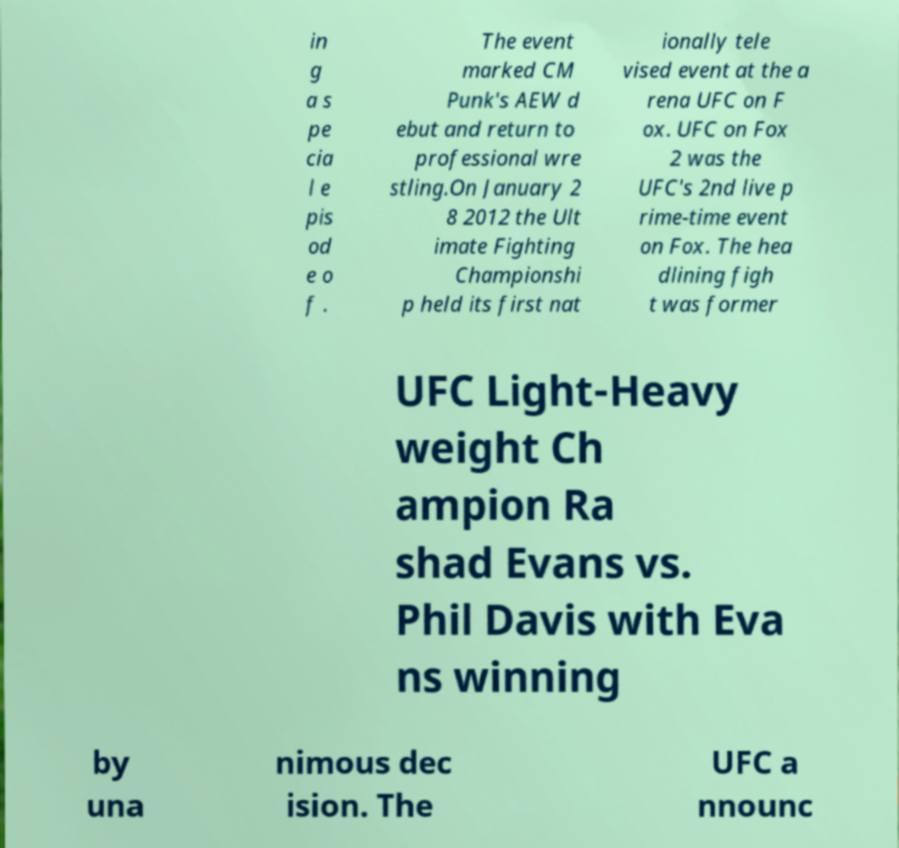There's text embedded in this image that I need extracted. Can you transcribe it verbatim? in g a s pe cia l e pis od e o f . The event marked CM Punk's AEW d ebut and return to professional wre stling.On January 2 8 2012 the Ult imate Fighting Championshi p held its first nat ionally tele vised event at the a rena UFC on F ox. UFC on Fox 2 was the UFC's 2nd live p rime-time event on Fox. The hea dlining figh t was former UFC Light-Heavy weight Ch ampion Ra shad Evans vs. Phil Davis with Eva ns winning by una nimous dec ision. The UFC a nnounc 